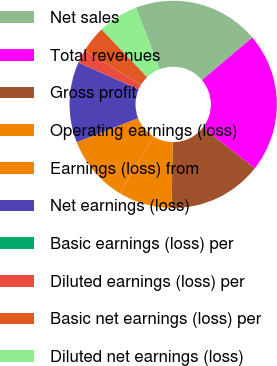<chart> <loc_0><loc_0><loc_500><loc_500><pie_chart><fcel>Net sales<fcel>Total revenues<fcel>Gross profit<fcel>Operating earnings (loss)<fcel>Earnings (loss) from<fcel>Net earnings (loss)<fcel>Basic earnings (loss) per<fcel>Diluted earnings (loss) per<fcel>Basic net earnings (loss) per<fcel>Diluted net earnings (loss)<nl><fcel>19.68%<fcel>21.77%<fcel>14.64%<fcel>8.36%<fcel>10.46%<fcel>12.55%<fcel>0.0%<fcel>2.09%<fcel>4.18%<fcel>6.27%<nl></chart> 